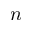Convert formula to latex. <formula><loc_0><loc_0><loc_500><loc_500>n</formula> 